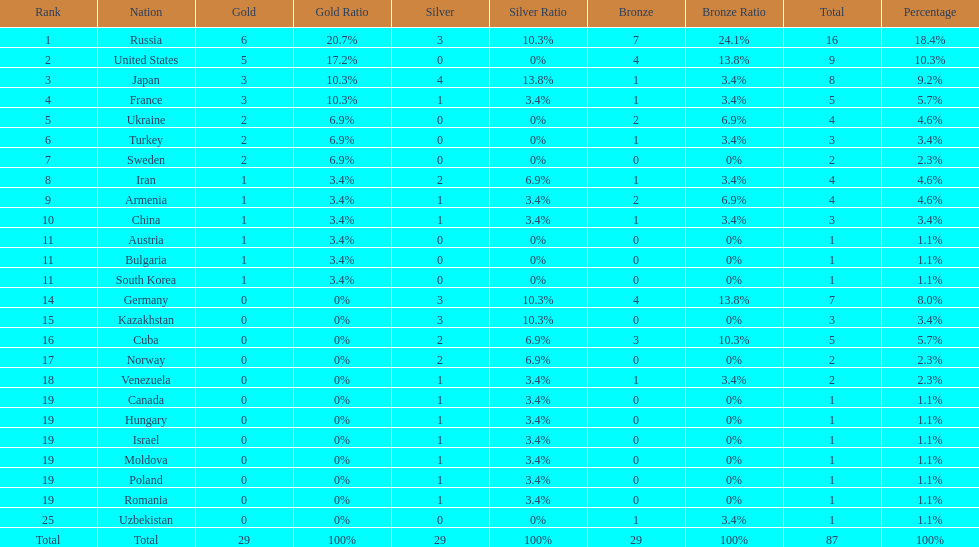Which country had the highest number of medals? Russia. 